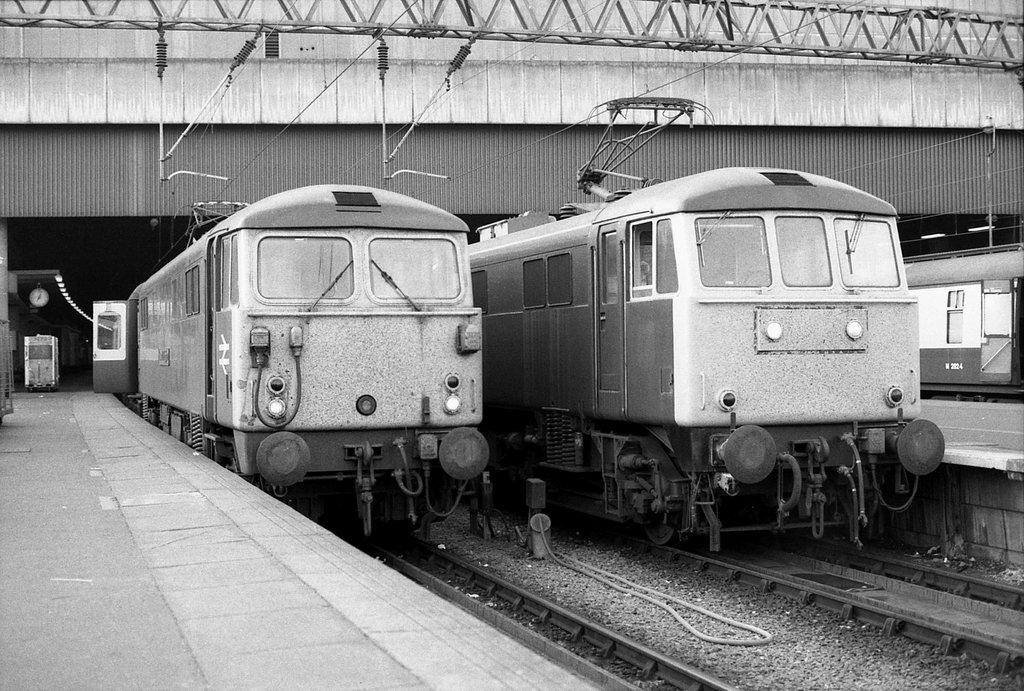What is the color scheme of the image? The image is black and white. What can be seen on the tracks in the image? There are trains on the tracks in the image. What type of structure is visible in the image? The image shows a platform. What time-related object is visible in the image? There is a clock visible in the image. What type of infrastructure is present in the image? Wires are present in the image. What else can be seen in the image that provides illumination? Lights are visible in the image. Can you tell me how many dogs are participating in the protest in the image? There are no dogs or protests present in the image; it features trains on tracks, a platform, a clock, wires, and lights. What type of musical instrument is being played by the person in the image? There is no person or musical instrument present in the image. 